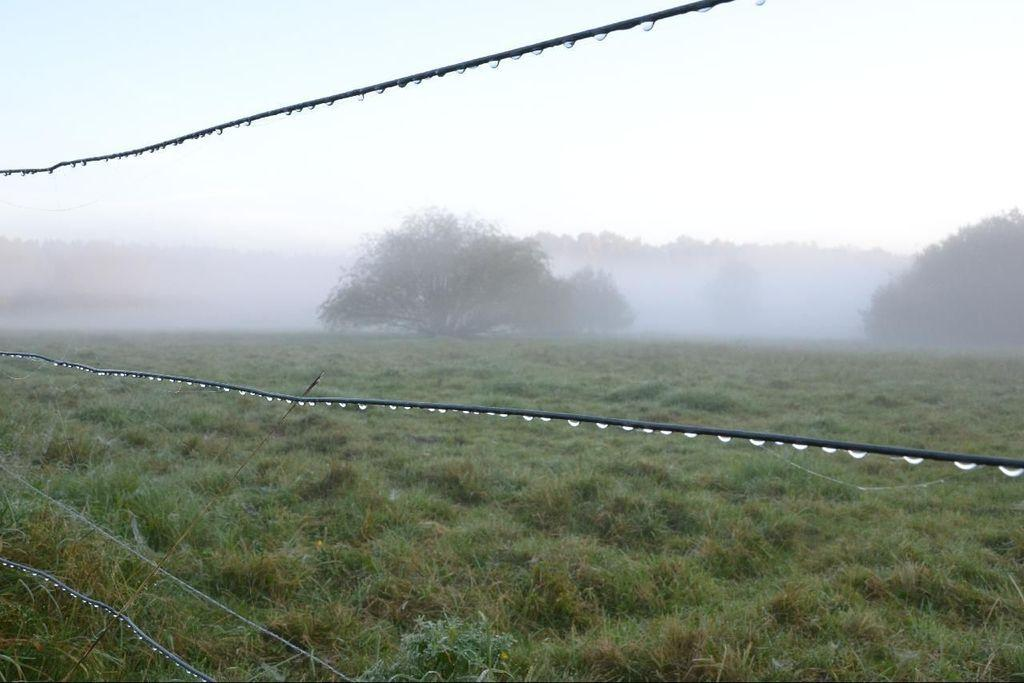What is hanging from the wires in the image? There are water droplets hanging from the wires in the image. What type of vegetation is present on the ground in the image? There is grass and small plants on the ground in the image. What can be seen in the background of the image? There are trees in the background of the image. What type of stone is present in the image? There is no stone present in the image. What direction is the zephyr blowing in the image? There is no zephyr present in the image; it is a term for a gentle breeze, and there is no indication of wind in the image. 